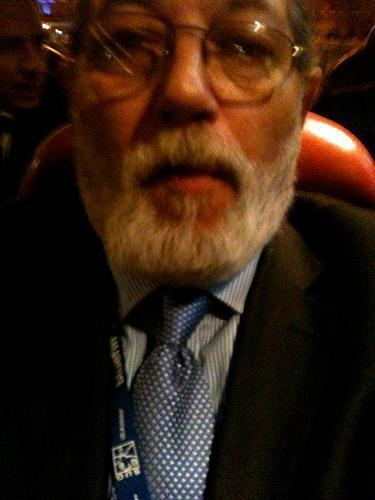How many people are there?
Give a very brief answer. 2. How many bananas are on the table?
Give a very brief answer. 0. 